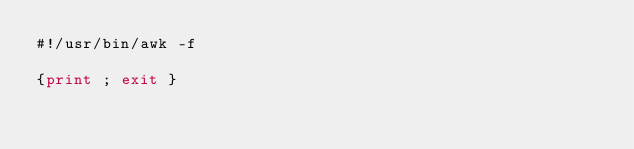Convert code to text. <code><loc_0><loc_0><loc_500><loc_500><_Awk_>#!/usr/bin/awk -f

{print ; exit }
</code> 